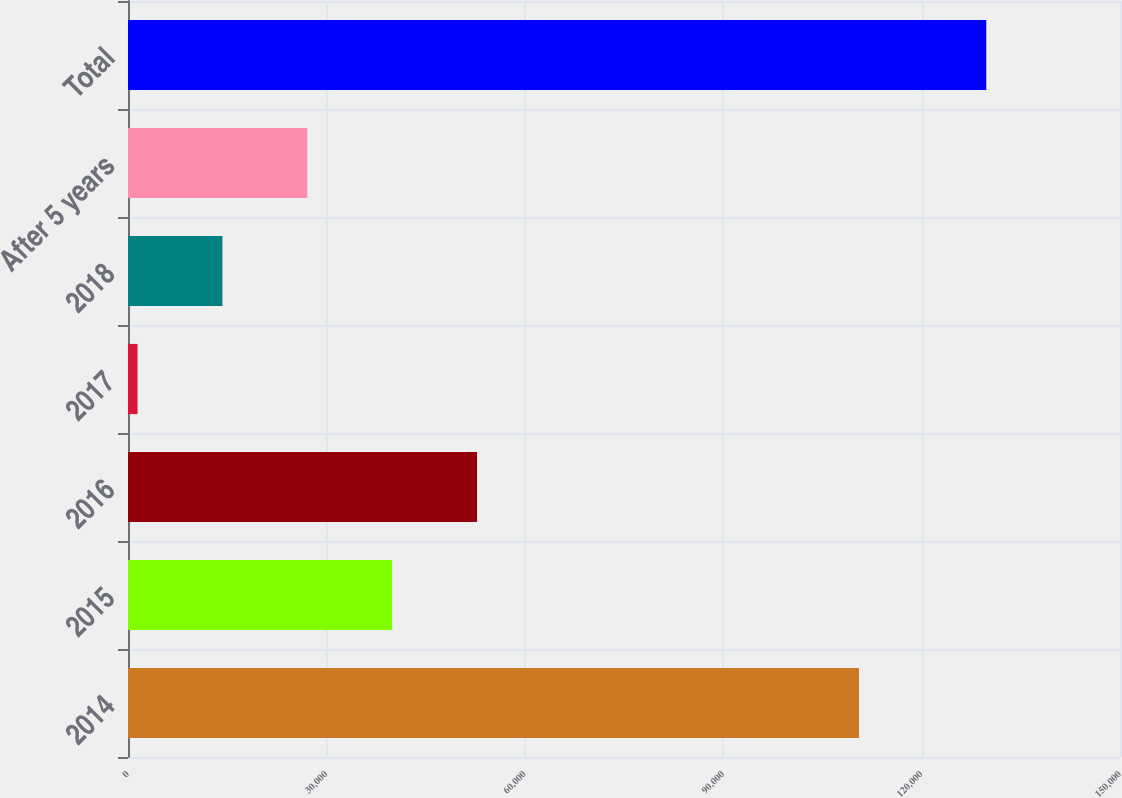<chart> <loc_0><loc_0><loc_500><loc_500><bar_chart><fcel>2014<fcel>2015<fcel>2016<fcel>2017<fcel>2018<fcel>After 5 years<fcel>Total<nl><fcel>110524<fcel>39943.7<fcel>52777.6<fcel>1442<fcel>14275.9<fcel>27109.8<fcel>129781<nl></chart> 